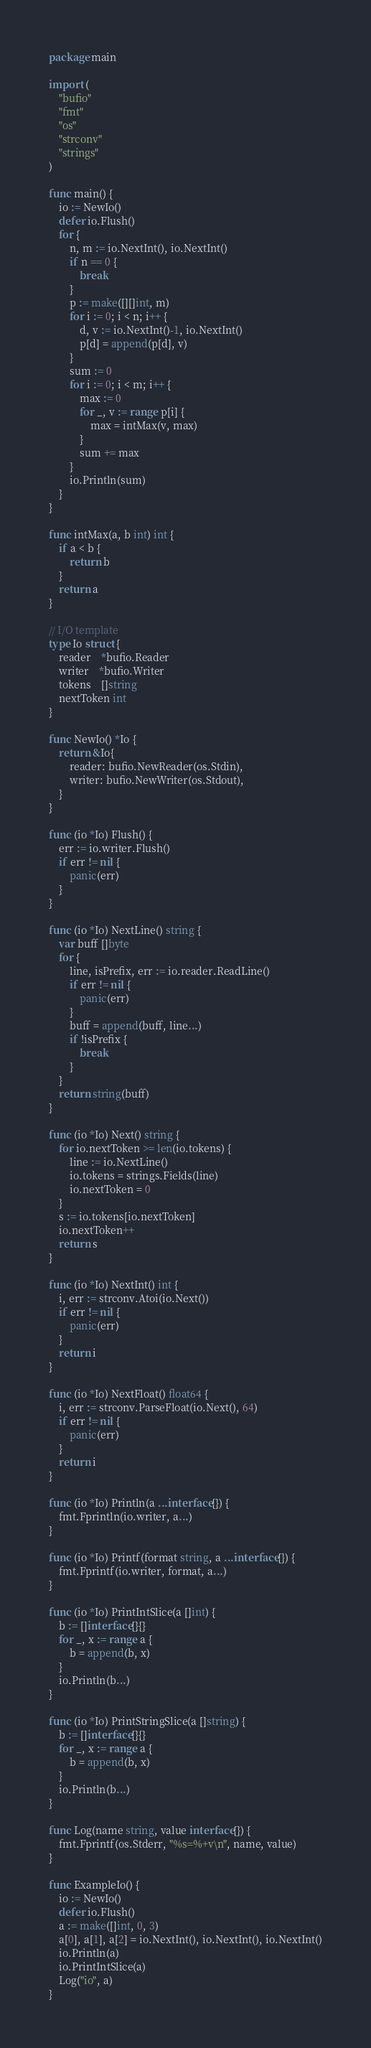<code> <loc_0><loc_0><loc_500><loc_500><_Go_>package main

import (
	"bufio"
	"fmt"
	"os"
	"strconv"
	"strings"
)

func main() {
	io := NewIo()
	defer io.Flush()
	for {
		n, m := io.NextInt(), io.NextInt()
		if n == 0 {
			break
		}
		p := make([][]int, m)
		for i := 0; i < n; i++ {
			d, v := io.NextInt()-1, io.NextInt()
			p[d] = append(p[d], v)
		}
		sum := 0
		for i := 0; i < m; i++ {
			max := 0
			for _, v := range p[i] {
				max = intMax(v, max)
			}
			sum += max
		}
		io.Println(sum)
	}
}

func intMax(a, b int) int {
	if a < b {
		return b
	}
	return a
}

// I/O template
type Io struct {
	reader    *bufio.Reader
	writer    *bufio.Writer
	tokens    []string
	nextToken int
}

func NewIo() *Io {
	return &Io{
		reader: bufio.NewReader(os.Stdin),
		writer: bufio.NewWriter(os.Stdout),
	}
}

func (io *Io) Flush() {
	err := io.writer.Flush()
	if err != nil {
		panic(err)
	}
}

func (io *Io) NextLine() string {
	var buff []byte
	for {
		line, isPrefix, err := io.reader.ReadLine()
		if err != nil {
			panic(err)
		}
		buff = append(buff, line...)
		if !isPrefix {
			break
		}
	}
	return string(buff)
}

func (io *Io) Next() string {
	for io.nextToken >= len(io.tokens) {
		line := io.NextLine()
		io.tokens = strings.Fields(line)
		io.nextToken = 0
	}
	s := io.tokens[io.nextToken]
	io.nextToken++
	return s
}

func (io *Io) NextInt() int {
	i, err := strconv.Atoi(io.Next())
	if err != nil {
		panic(err)
	}
	return i
}

func (io *Io) NextFloat() float64 {
	i, err := strconv.ParseFloat(io.Next(), 64)
	if err != nil {
		panic(err)
	}
	return i
}

func (io *Io) Println(a ...interface{}) {
	fmt.Fprintln(io.writer, a...)
}

func (io *Io) Printf(format string, a ...interface{}) {
	fmt.Fprintf(io.writer, format, a...)
}

func (io *Io) PrintIntSlice(a []int) {
	b := []interface{}{}
	for _, x := range a {
		b = append(b, x)
	}
	io.Println(b...)
}

func (io *Io) PrintStringSlice(a []string) {
	b := []interface{}{}
	for _, x := range a {
		b = append(b, x)
	}
	io.Println(b...)
}

func Log(name string, value interface{}) {
	fmt.Fprintf(os.Stderr, "%s=%+v\n", name, value)
}

func ExampleIo() {
	io := NewIo()
	defer io.Flush()
	a := make([]int, 0, 3)
	a[0], a[1], a[2] = io.NextInt(), io.NextInt(), io.NextInt()
	io.Println(a)
	io.PrintIntSlice(a)
	Log("io", a)
}

</code> 